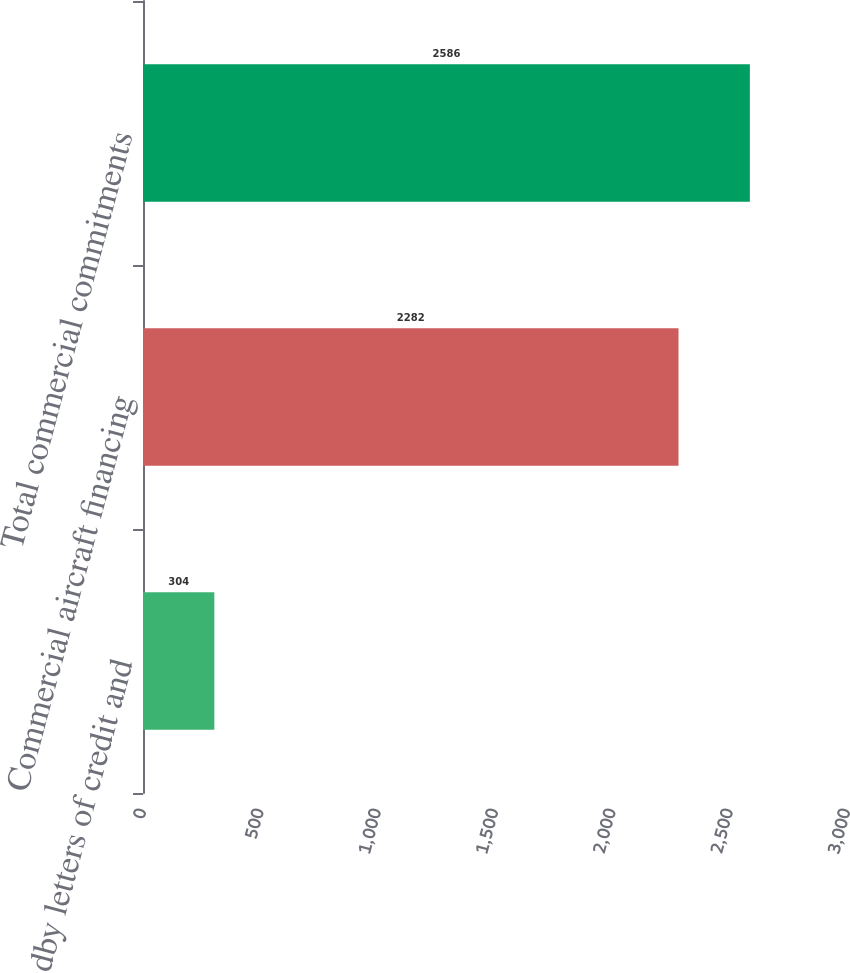<chart> <loc_0><loc_0><loc_500><loc_500><bar_chart><fcel>Standby letters of credit and<fcel>Commercial aircraft financing<fcel>Total commercial commitments<nl><fcel>304<fcel>2282<fcel>2586<nl></chart> 